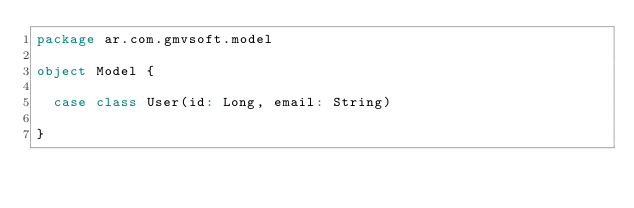Convert code to text. <code><loc_0><loc_0><loc_500><loc_500><_Scala_>package ar.com.gmvsoft.model

object Model {

  case class User(id: Long, email: String)

}
</code> 